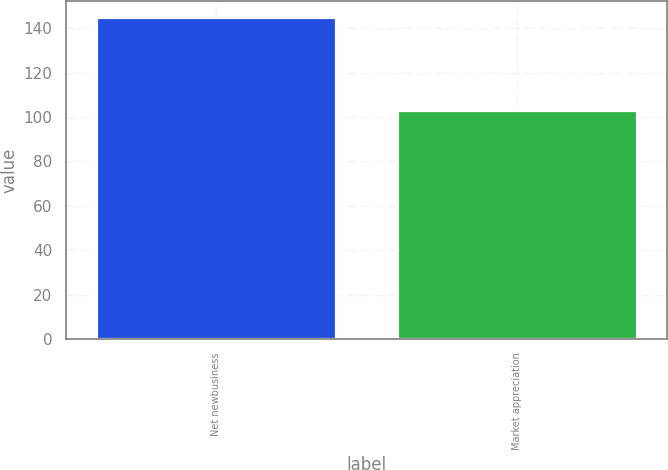Convert chart. <chart><loc_0><loc_0><loc_500><loc_500><bar_chart><fcel>Net newbusiness<fcel>Market appreciation<nl><fcel>145<fcel>103<nl></chart> 